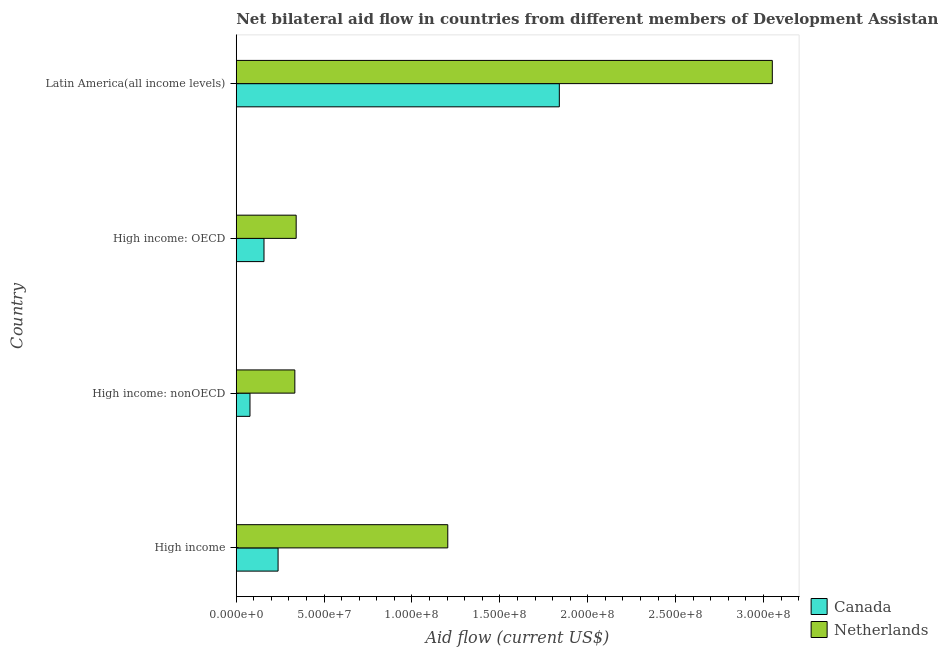Are the number of bars per tick equal to the number of legend labels?
Offer a terse response. Yes. Are the number of bars on each tick of the Y-axis equal?
Ensure brevity in your answer.  Yes. How many bars are there on the 4th tick from the top?
Provide a short and direct response. 2. How many bars are there on the 4th tick from the bottom?
Provide a succinct answer. 2. What is the label of the 2nd group of bars from the top?
Provide a succinct answer. High income: OECD. What is the amount of aid given by netherlands in High income: nonOECD?
Your answer should be compact. 3.33e+07. Across all countries, what is the maximum amount of aid given by canada?
Offer a terse response. 1.84e+08. Across all countries, what is the minimum amount of aid given by canada?
Your answer should be compact. 7.81e+06. In which country was the amount of aid given by netherlands maximum?
Keep it short and to the point. Latin America(all income levels). In which country was the amount of aid given by netherlands minimum?
Your response must be concise. High income: nonOECD. What is the total amount of aid given by canada in the graph?
Give a very brief answer. 2.31e+08. What is the difference between the amount of aid given by netherlands in High income: OECD and that in High income: nonOECD?
Your response must be concise. 7.60e+05. What is the difference between the amount of aid given by canada in High income: nonOECD and the amount of aid given by netherlands in Latin America(all income levels)?
Keep it short and to the point. -2.97e+08. What is the average amount of aid given by canada per country?
Provide a succinct answer. 5.78e+07. What is the difference between the amount of aid given by netherlands and amount of aid given by canada in High income: nonOECD?
Your answer should be compact. 2.55e+07. In how many countries, is the amount of aid given by netherlands greater than 180000000 US$?
Keep it short and to the point. 1. What is the ratio of the amount of aid given by netherlands in High income: OECD to that in Latin America(all income levels)?
Offer a terse response. 0.11. Is the amount of aid given by canada in High income less than that in Latin America(all income levels)?
Give a very brief answer. Yes. Is the difference between the amount of aid given by canada in High income and Latin America(all income levels) greater than the difference between the amount of aid given by netherlands in High income and Latin America(all income levels)?
Ensure brevity in your answer.  Yes. What is the difference between the highest and the second highest amount of aid given by canada?
Offer a very short reply. 1.60e+08. What is the difference between the highest and the lowest amount of aid given by canada?
Your answer should be compact. 1.76e+08. In how many countries, is the amount of aid given by canada greater than the average amount of aid given by canada taken over all countries?
Your answer should be very brief. 1. What does the 1st bar from the top in Latin America(all income levels) represents?
Your answer should be very brief. Netherlands. How many bars are there?
Your answer should be very brief. 8. Are all the bars in the graph horizontal?
Keep it short and to the point. Yes. Are the values on the major ticks of X-axis written in scientific E-notation?
Provide a succinct answer. Yes. Does the graph contain grids?
Ensure brevity in your answer.  No. Where does the legend appear in the graph?
Provide a succinct answer. Bottom right. How many legend labels are there?
Ensure brevity in your answer.  2. How are the legend labels stacked?
Your response must be concise. Vertical. What is the title of the graph?
Offer a very short reply. Net bilateral aid flow in countries from different members of Development Assistance Committee. Does "Techinal cooperation" appear as one of the legend labels in the graph?
Offer a very short reply. No. What is the label or title of the Y-axis?
Make the answer very short. Country. What is the Aid flow (current US$) of Canada in High income?
Ensure brevity in your answer.  2.38e+07. What is the Aid flow (current US$) in Netherlands in High income?
Provide a succinct answer. 1.20e+08. What is the Aid flow (current US$) of Canada in High income: nonOECD?
Offer a very short reply. 7.81e+06. What is the Aid flow (current US$) of Netherlands in High income: nonOECD?
Ensure brevity in your answer.  3.33e+07. What is the Aid flow (current US$) in Canada in High income: OECD?
Your response must be concise. 1.58e+07. What is the Aid flow (current US$) in Netherlands in High income: OECD?
Give a very brief answer. 3.41e+07. What is the Aid flow (current US$) in Canada in Latin America(all income levels)?
Provide a succinct answer. 1.84e+08. What is the Aid flow (current US$) in Netherlands in Latin America(all income levels)?
Ensure brevity in your answer.  3.05e+08. Across all countries, what is the maximum Aid flow (current US$) of Canada?
Provide a short and direct response. 1.84e+08. Across all countries, what is the maximum Aid flow (current US$) in Netherlands?
Your response must be concise. 3.05e+08. Across all countries, what is the minimum Aid flow (current US$) in Canada?
Your response must be concise. 7.81e+06. Across all countries, what is the minimum Aid flow (current US$) in Netherlands?
Offer a terse response. 3.33e+07. What is the total Aid flow (current US$) of Canada in the graph?
Ensure brevity in your answer.  2.31e+08. What is the total Aid flow (current US$) of Netherlands in the graph?
Provide a short and direct response. 4.93e+08. What is the difference between the Aid flow (current US$) of Canada in High income and that in High income: nonOECD?
Your answer should be very brief. 1.60e+07. What is the difference between the Aid flow (current US$) in Netherlands in High income and that in High income: nonOECD?
Give a very brief answer. 8.70e+07. What is the difference between the Aid flow (current US$) of Canada in High income and that in High income: OECD?
Offer a terse response. 8.01e+06. What is the difference between the Aid flow (current US$) of Netherlands in High income and that in High income: OECD?
Your response must be concise. 8.63e+07. What is the difference between the Aid flow (current US$) in Canada in High income and that in Latin America(all income levels)?
Your answer should be compact. -1.60e+08. What is the difference between the Aid flow (current US$) in Netherlands in High income and that in Latin America(all income levels)?
Your answer should be very brief. -1.85e+08. What is the difference between the Aid flow (current US$) in Canada in High income: nonOECD and that in High income: OECD?
Ensure brevity in your answer.  -7.98e+06. What is the difference between the Aid flow (current US$) of Netherlands in High income: nonOECD and that in High income: OECD?
Keep it short and to the point. -7.60e+05. What is the difference between the Aid flow (current US$) of Canada in High income: nonOECD and that in Latin America(all income levels)?
Keep it short and to the point. -1.76e+08. What is the difference between the Aid flow (current US$) in Netherlands in High income: nonOECD and that in Latin America(all income levels)?
Provide a succinct answer. -2.72e+08. What is the difference between the Aid flow (current US$) in Canada in High income: OECD and that in Latin America(all income levels)?
Keep it short and to the point. -1.68e+08. What is the difference between the Aid flow (current US$) of Netherlands in High income: OECD and that in Latin America(all income levels)?
Offer a very short reply. -2.71e+08. What is the difference between the Aid flow (current US$) of Canada in High income and the Aid flow (current US$) of Netherlands in High income: nonOECD?
Offer a very short reply. -9.54e+06. What is the difference between the Aid flow (current US$) in Canada in High income and the Aid flow (current US$) in Netherlands in High income: OECD?
Make the answer very short. -1.03e+07. What is the difference between the Aid flow (current US$) of Canada in High income and the Aid flow (current US$) of Netherlands in Latin America(all income levels)?
Offer a very short reply. -2.81e+08. What is the difference between the Aid flow (current US$) in Canada in High income: nonOECD and the Aid flow (current US$) in Netherlands in High income: OECD?
Ensure brevity in your answer.  -2.63e+07. What is the difference between the Aid flow (current US$) of Canada in High income: nonOECD and the Aid flow (current US$) of Netherlands in Latin America(all income levels)?
Offer a terse response. -2.97e+08. What is the difference between the Aid flow (current US$) of Canada in High income: OECD and the Aid flow (current US$) of Netherlands in Latin America(all income levels)?
Ensure brevity in your answer.  -2.89e+08. What is the average Aid flow (current US$) in Canada per country?
Your answer should be compact. 5.78e+07. What is the average Aid flow (current US$) of Netherlands per country?
Offer a very short reply. 1.23e+08. What is the difference between the Aid flow (current US$) in Canada and Aid flow (current US$) in Netherlands in High income?
Provide a succinct answer. -9.66e+07. What is the difference between the Aid flow (current US$) in Canada and Aid flow (current US$) in Netherlands in High income: nonOECD?
Ensure brevity in your answer.  -2.55e+07. What is the difference between the Aid flow (current US$) of Canada and Aid flow (current US$) of Netherlands in High income: OECD?
Keep it short and to the point. -1.83e+07. What is the difference between the Aid flow (current US$) in Canada and Aid flow (current US$) in Netherlands in Latin America(all income levels)?
Ensure brevity in your answer.  -1.21e+08. What is the ratio of the Aid flow (current US$) in Canada in High income to that in High income: nonOECD?
Provide a succinct answer. 3.05. What is the ratio of the Aid flow (current US$) of Netherlands in High income to that in High income: nonOECD?
Your response must be concise. 3.61. What is the ratio of the Aid flow (current US$) in Canada in High income to that in High income: OECD?
Give a very brief answer. 1.51. What is the ratio of the Aid flow (current US$) in Netherlands in High income to that in High income: OECD?
Provide a succinct answer. 3.53. What is the ratio of the Aid flow (current US$) in Canada in High income to that in Latin America(all income levels)?
Make the answer very short. 0.13. What is the ratio of the Aid flow (current US$) in Netherlands in High income to that in Latin America(all income levels)?
Give a very brief answer. 0.39. What is the ratio of the Aid flow (current US$) in Canada in High income: nonOECD to that in High income: OECD?
Provide a succinct answer. 0.49. What is the ratio of the Aid flow (current US$) in Netherlands in High income: nonOECD to that in High income: OECD?
Ensure brevity in your answer.  0.98. What is the ratio of the Aid flow (current US$) in Canada in High income: nonOECD to that in Latin America(all income levels)?
Your response must be concise. 0.04. What is the ratio of the Aid flow (current US$) of Netherlands in High income: nonOECD to that in Latin America(all income levels)?
Your response must be concise. 0.11. What is the ratio of the Aid flow (current US$) in Canada in High income: OECD to that in Latin America(all income levels)?
Your answer should be very brief. 0.09. What is the ratio of the Aid flow (current US$) in Netherlands in High income: OECD to that in Latin America(all income levels)?
Provide a short and direct response. 0.11. What is the difference between the highest and the second highest Aid flow (current US$) of Canada?
Your response must be concise. 1.60e+08. What is the difference between the highest and the second highest Aid flow (current US$) of Netherlands?
Give a very brief answer. 1.85e+08. What is the difference between the highest and the lowest Aid flow (current US$) of Canada?
Make the answer very short. 1.76e+08. What is the difference between the highest and the lowest Aid flow (current US$) of Netherlands?
Provide a succinct answer. 2.72e+08. 